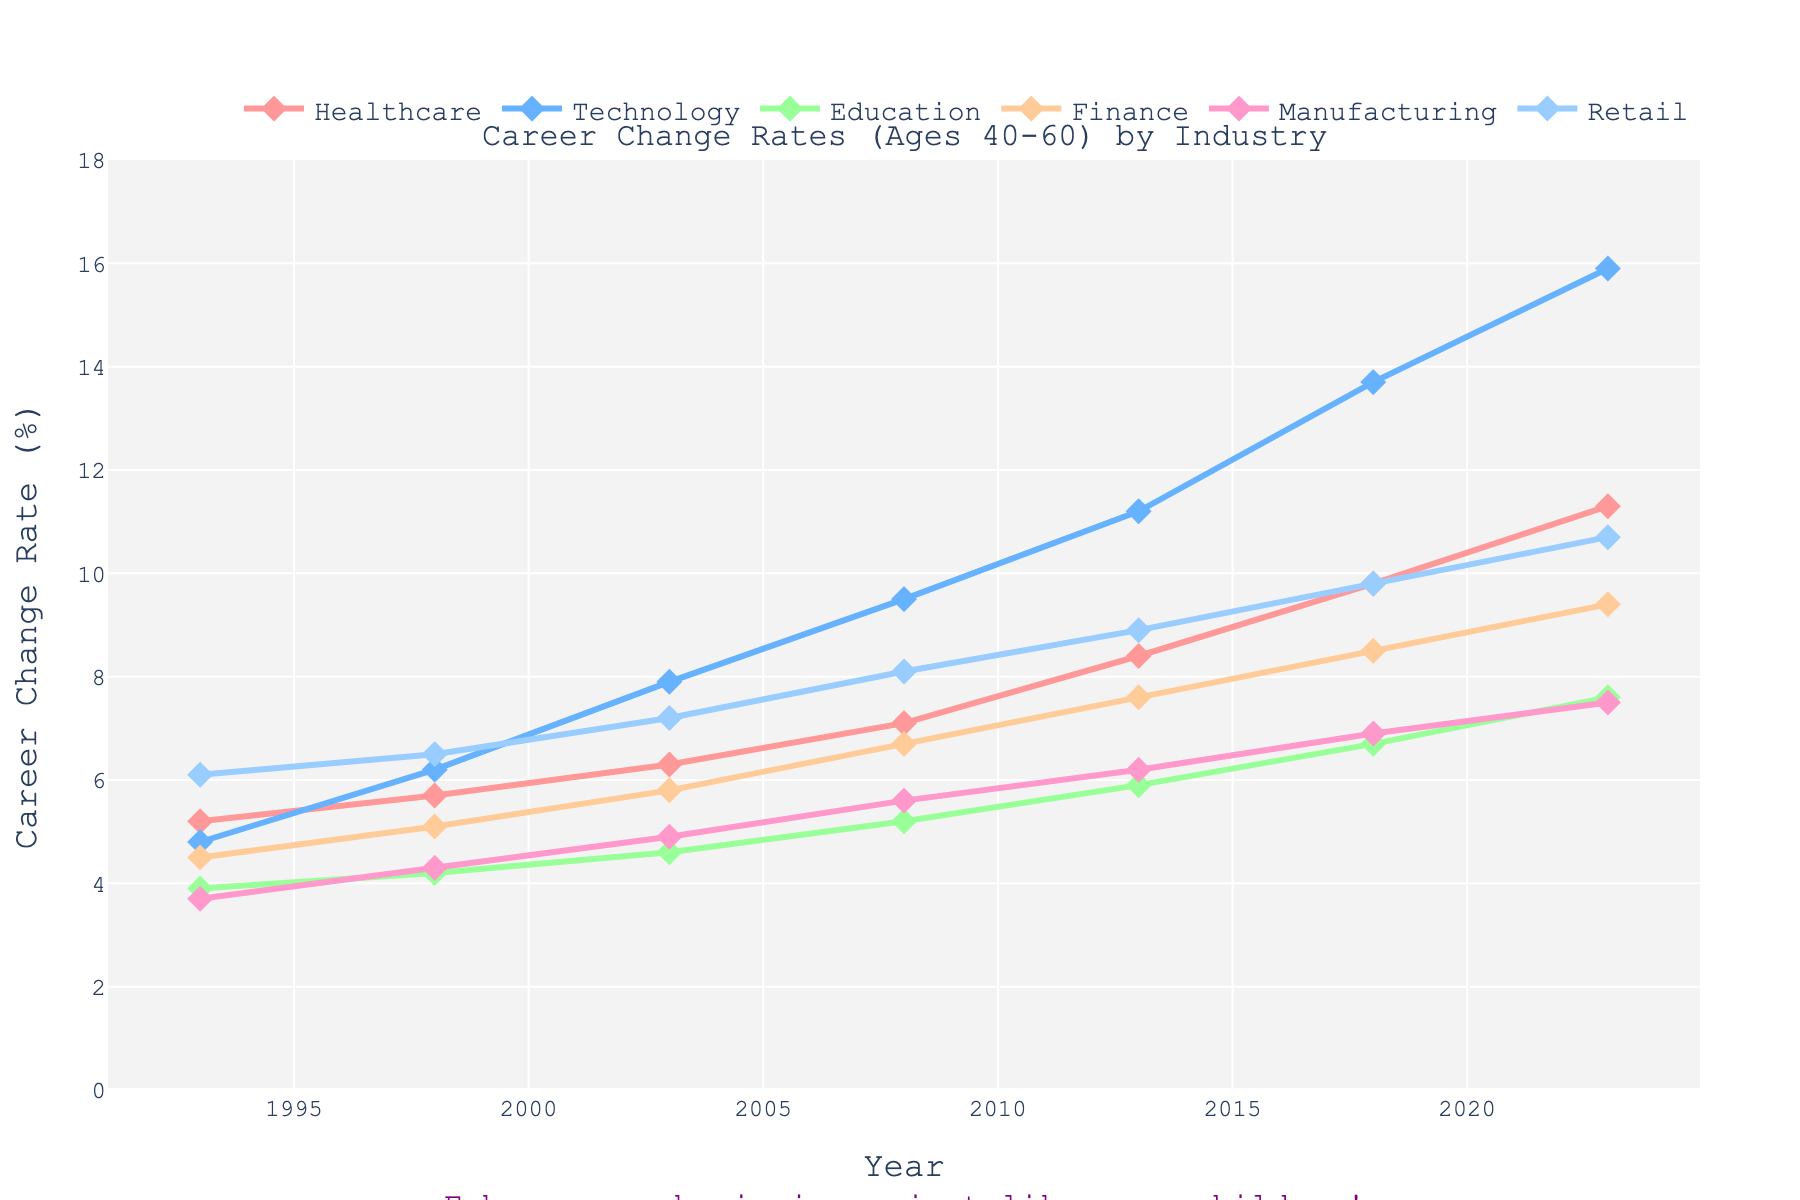What is the career change rate for the Healthcare industry in 2008? Locate Healthcare in the legend and then find the corresponding line. Trace the line to the year 2008 to find the value on the y-axis.
Answer: 7.1 Which industry has the highest career change rate in 2023? Identify the lines at the year 2023 and determine which line reaches the highest point on the y-axis.
Answer: Technology What is the average career change rate for the Technology industry over the 30 years? Add the values of the Technology industry from 1993 to 2023 and divide by the number of values. (4.8 + 6.2 + 7.9 + 9.5 + 11.2 + 13.7 + 15.9) / 7 = 69.2 / 7 = 9.89
Answer: 9.89 How much did the career change rate for the Retail industry increase from 1993 to 2023? Subtract the value in 1993 from the value in 2023 for the Retail industry. 10.7 - 6.1
Answer: 4.6 Which industry saw the smallest increase in career change rate from 1993 to 2023? Calculate the difference for each industry from 1993 to 2023 and identify the smallest. (2.4 for Healthcare, 11.1 for Technology, 3.7 for Education, 4.9 for Finance, 3.8 for Manufacturing, 4.6 for Retail)
Answer: Education During which period did the Finance industry experience the largest increase in career change rate, and what was the increase? Compare the increments between consecutive years for the Finance industry. The increases are (4.5 to 5.1), (5.1 to 5.8), (5.8 to 6.7), (6.7 to 7.6), (7.6 to 8.5), (8.5 to 9.4), with the largest being 0.9 from 2008 to 2013.
Answer: 2008-2013, 0.9 By how much did the career change rate in Healthcare increase from 2013 to 2018 compared to the increase from 2018 to 2023? Calculate the difference between 2013-2018 (9.8 - 8.4 = 1.4) and 2018-2023 (11.3 - 9.8 = 1.5) and then compare the two values. 1.5 - 1.4
Answer: 0.1 Which two industries are closest in career change rate in the year 2013 and what are their rates? Compare the values for all industries in 2013 and identify the closest pair. (Healthcare 8.4, Technology 11.2, Education 5.9, Finance 7.6, Manufacturing 6.2, Retail 8.9) The closest pair is Finance and Manufacturing with a difference of 1.4.
Answer: Finance (7.6) and Manufacturing (6.2) What is the overall trend in career change rates for the Manufacturing industry from 1993 to 2023? Identify the values for Manufacturing over the years and describe the progression. The values are: 3.7, 4.3, 4.9, 5.6, 6.2, 6.9, 7.5 indicating an overall upward trend.
Answer: Upward trend During which 5-year interval did the Education industry experience the slowest growth in career change rate? Calculate the increase for each 5-year period in the Education data: (3.9 to 4.2), (4.2 to 4.6), (4.6 to 5.2), (5.2 to 5.9), (5.9 to 6.7), (6.7 to 7.6). The smallest increase is 0.3 from 1993 to 1998.
Answer: 1993-1998 